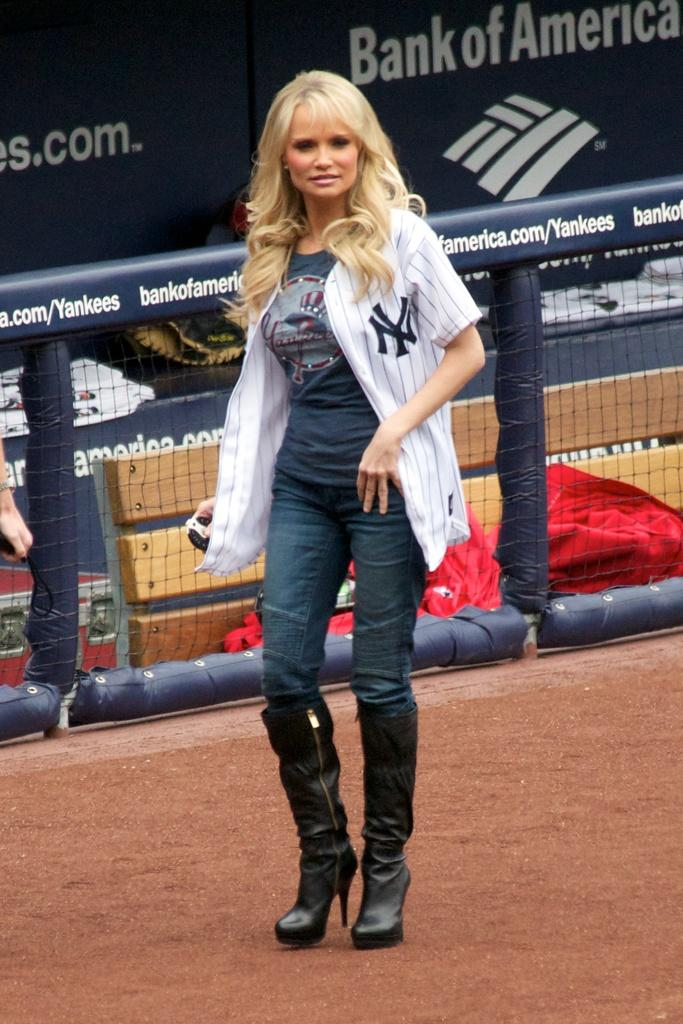<image>
Describe the image concisely. A woman with blonde hair and a New YOrk Yankees jersey is walking in front of the dugout in tall black boots. 